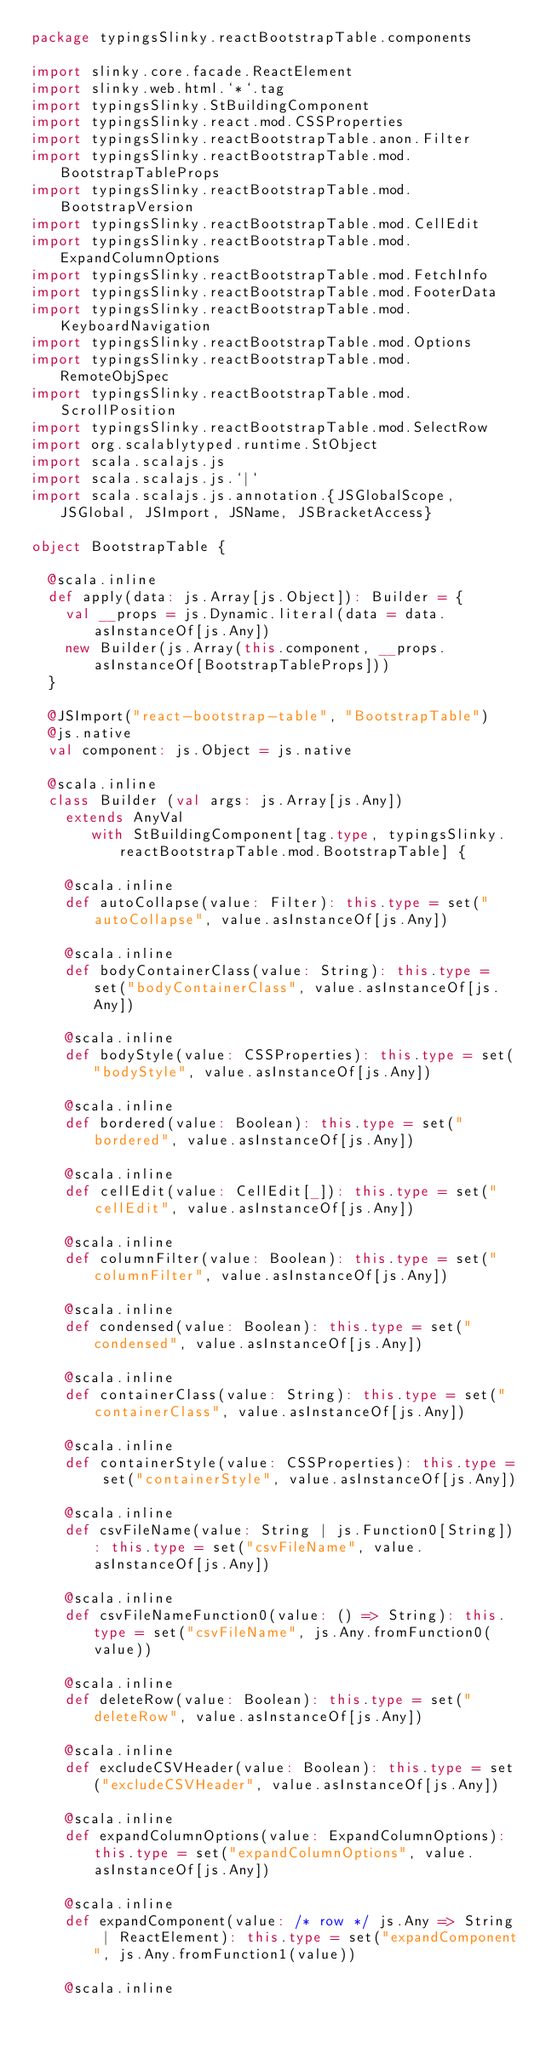<code> <loc_0><loc_0><loc_500><loc_500><_Scala_>package typingsSlinky.reactBootstrapTable.components

import slinky.core.facade.ReactElement
import slinky.web.html.`*`.tag
import typingsSlinky.StBuildingComponent
import typingsSlinky.react.mod.CSSProperties
import typingsSlinky.reactBootstrapTable.anon.Filter
import typingsSlinky.reactBootstrapTable.mod.BootstrapTableProps
import typingsSlinky.reactBootstrapTable.mod.BootstrapVersion
import typingsSlinky.reactBootstrapTable.mod.CellEdit
import typingsSlinky.reactBootstrapTable.mod.ExpandColumnOptions
import typingsSlinky.reactBootstrapTable.mod.FetchInfo
import typingsSlinky.reactBootstrapTable.mod.FooterData
import typingsSlinky.reactBootstrapTable.mod.KeyboardNavigation
import typingsSlinky.reactBootstrapTable.mod.Options
import typingsSlinky.reactBootstrapTable.mod.RemoteObjSpec
import typingsSlinky.reactBootstrapTable.mod.ScrollPosition
import typingsSlinky.reactBootstrapTable.mod.SelectRow
import org.scalablytyped.runtime.StObject
import scala.scalajs.js
import scala.scalajs.js.`|`
import scala.scalajs.js.annotation.{JSGlobalScope, JSGlobal, JSImport, JSName, JSBracketAccess}

object BootstrapTable {
  
  @scala.inline
  def apply(data: js.Array[js.Object]): Builder = {
    val __props = js.Dynamic.literal(data = data.asInstanceOf[js.Any])
    new Builder(js.Array(this.component, __props.asInstanceOf[BootstrapTableProps]))
  }
  
  @JSImport("react-bootstrap-table", "BootstrapTable")
  @js.native
  val component: js.Object = js.native
  
  @scala.inline
  class Builder (val args: js.Array[js.Any])
    extends AnyVal
       with StBuildingComponent[tag.type, typingsSlinky.reactBootstrapTable.mod.BootstrapTable] {
    
    @scala.inline
    def autoCollapse(value: Filter): this.type = set("autoCollapse", value.asInstanceOf[js.Any])
    
    @scala.inline
    def bodyContainerClass(value: String): this.type = set("bodyContainerClass", value.asInstanceOf[js.Any])
    
    @scala.inline
    def bodyStyle(value: CSSProperties): this.type = set("bodyStyle", value.asInstanceOf[js.Any])
    
    @scala.inline
    def bordered(value: Boolean): this.type = set("bordered", value.asInstanceOf[js.Any])
    
    @scala.inline
    def cellEdit(value: CellEdit[_]): this.type = set("cellEdit", value.asInstanceOf[js.Any])
    
    @scala.inline
    def columnFilter(value: Boolean): this.type = set("columnFilter", value.asInstanceOf[js.Any])
    
    @scala.inline
    def condensed(value: Boolean): this.type = set("condensed", value.asInstanceOf[js.Any])
    
    @scala.inline
    def containerClass(value: String): this.type = set("containerClass", value.asInstanceOf[js.Any])
    
    @scala.inline
    def containerStyle(value: CSSProperties): this.type = set("containerStyle", value.asInstanceOf[js.Any])
    
    @scala.inline
    def csvFileName(value: String | js.Function0[String]): this.type = set("csvFileName", value.asInstanceOf[js.Any])
    
    @scala.inline
    def csvFileNameFunction0(value: () => String): this.type = set("csvFileName", js.Any.fromFunction0(value))
    
    @scala.inline
    def deleteRow(value: Boolean): this.type = set("deleteRow", value.asInstanceOf[js.Any])
    
    @scala.inline
    def excludeCSVHeader(value: Boolean): this.type = set("excludeCSVHeader", value.asInstanceOf[js.Any])
    
    @scala.inline
    def expandColumnOptions(value: ExpandColumnOptions): this.type = set("expandColumnOptions", value.asInstanceOf[js.Any])
    
    @scala.inline
    def expandComponent(value: /* row */ js.Any => String | ReactElement): this.type = set("expandComponent", js.Any.fromFunction1(value))
    
    @scala.inline</code> 